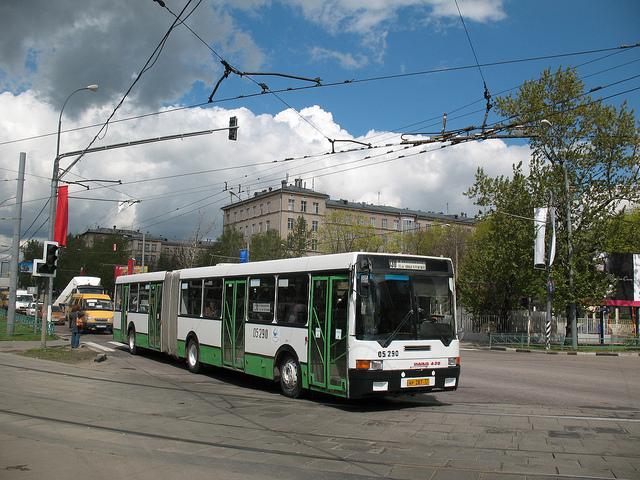What color is the sky?
Short answer required. Blue. What color are the buses?
Answer briefly. White and green. Is this a city scene?
Quick response, please. Yes. Is this an extended bus?
Quick response, please. Yes. 